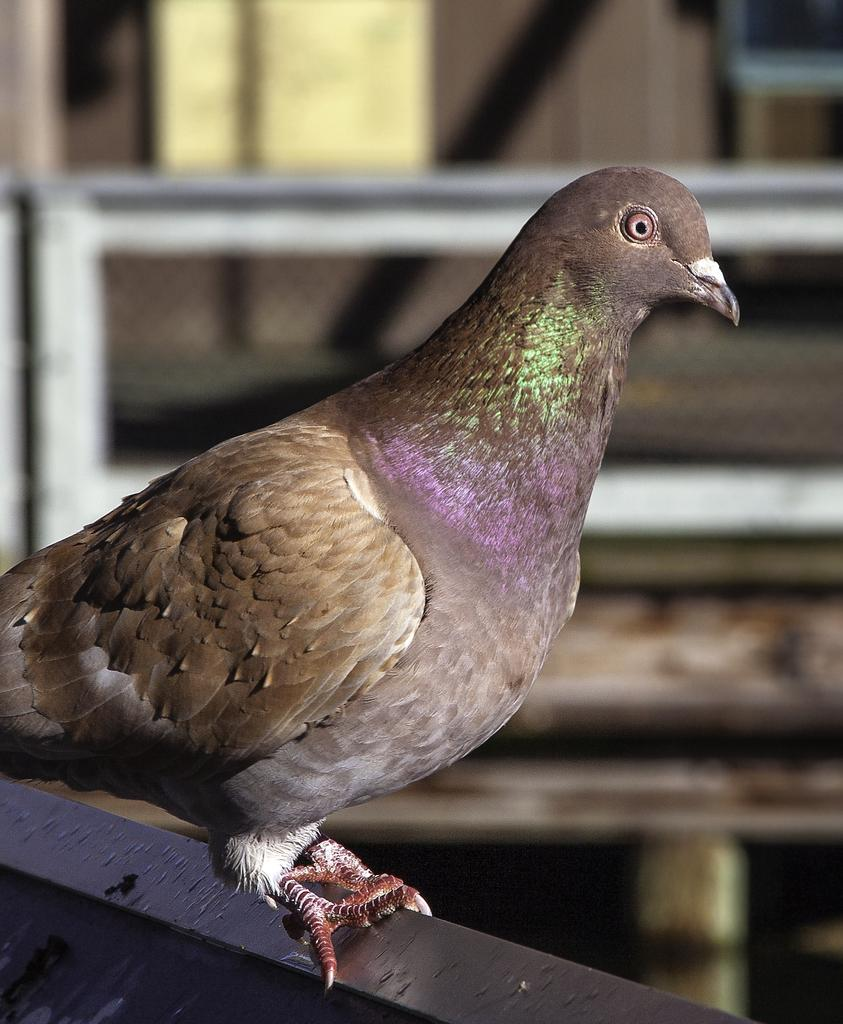What type of animal is present in the image? There is a bird in the image. What is the bird sitting on? The bird is on a black object. Can you describe the background of the image? There are other things visible in the background of the image. Reasoning: Let' Let's think step by step in order to produce the conversation. We start by identifying the main subject in the image, which is the bird. Then, we describe the bird's position and the object it is sitting on. Finally, we acknowledge the presence of other elements in the background, without specifying their nature. Absurd Question/Answer: What type of control does the bird have over the market in the image? There is no mention of a market or control in the image; it only features a bird on a black object with other things visible in the background. 